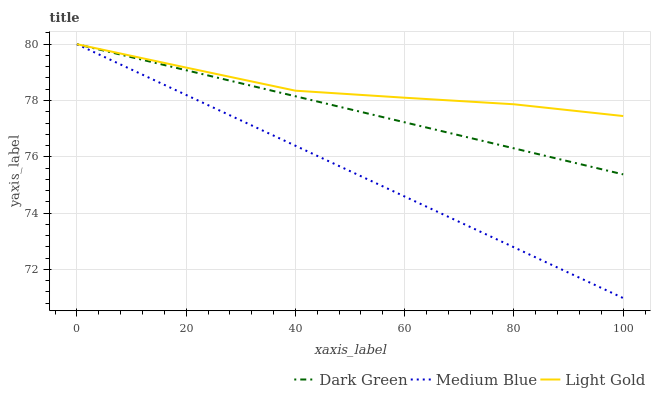Does Medium Blue have the minimum area under the curve?
Answer yes or no. Yes. Does Light Gold have the maximum area under the curve?
Answer yes or no. Yes. Does Dark Green have the minimum area under the curve?
Answer yes or no. No. Does Dark Green have the maximum area under the curve?
Answer yes or no. No. Is Medium Blue the smoothest?
Answer yes or no. Yes. Is Light Gold the roughest?
Answer yes or no. Yes. Is Dark Green the smoothest?
Answer yes or no. No. Is Dark Green the roughest?
Answer yes or no. No. Does Medium Blue have the lowest value?
Answer yes or no. Yes. Does Dark Green have the lowest value?
Answer yes or no. No. Does Dark Green have the highest value?
Answer yes or no. Yes. Does Dark Green intersect Light Gold?
Answer yes or no. Yes. Is Dark Green less than Light Gold?
Answer yes or no. No. Is Dark Green greater than Light Gold?
Answer yes or no. No. 